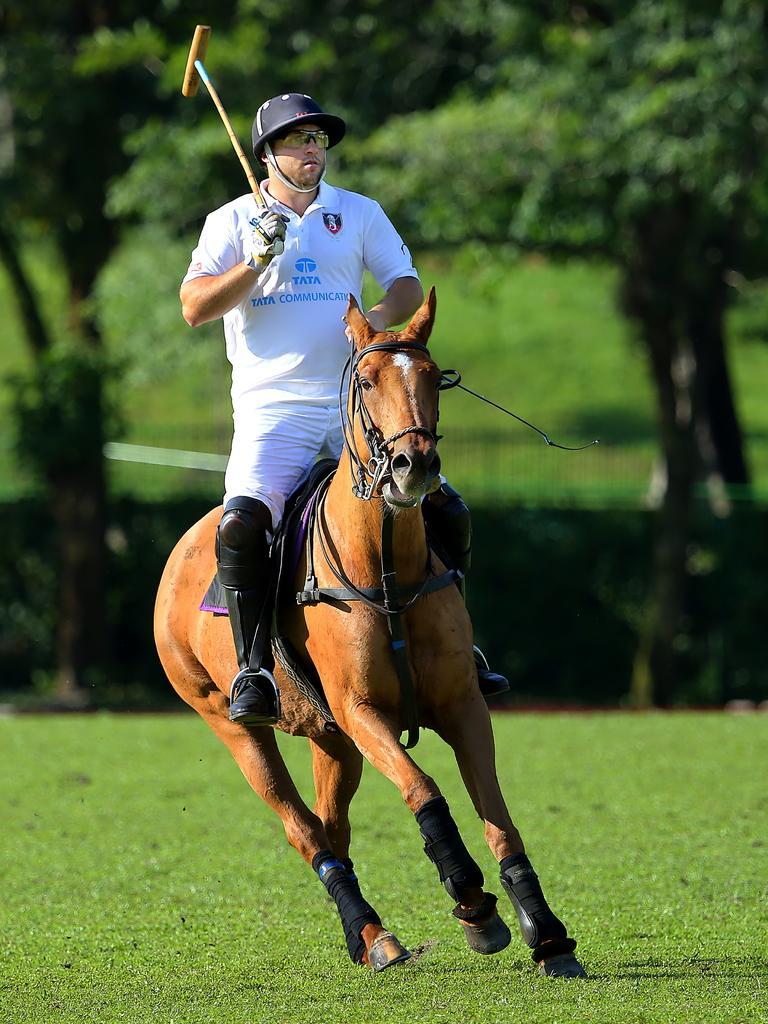Could you give a brief overview of what you see in this image? In this image there is a person holding an object and sitting on the horse, which is running on the surface of the grass. In the background there are trees. 